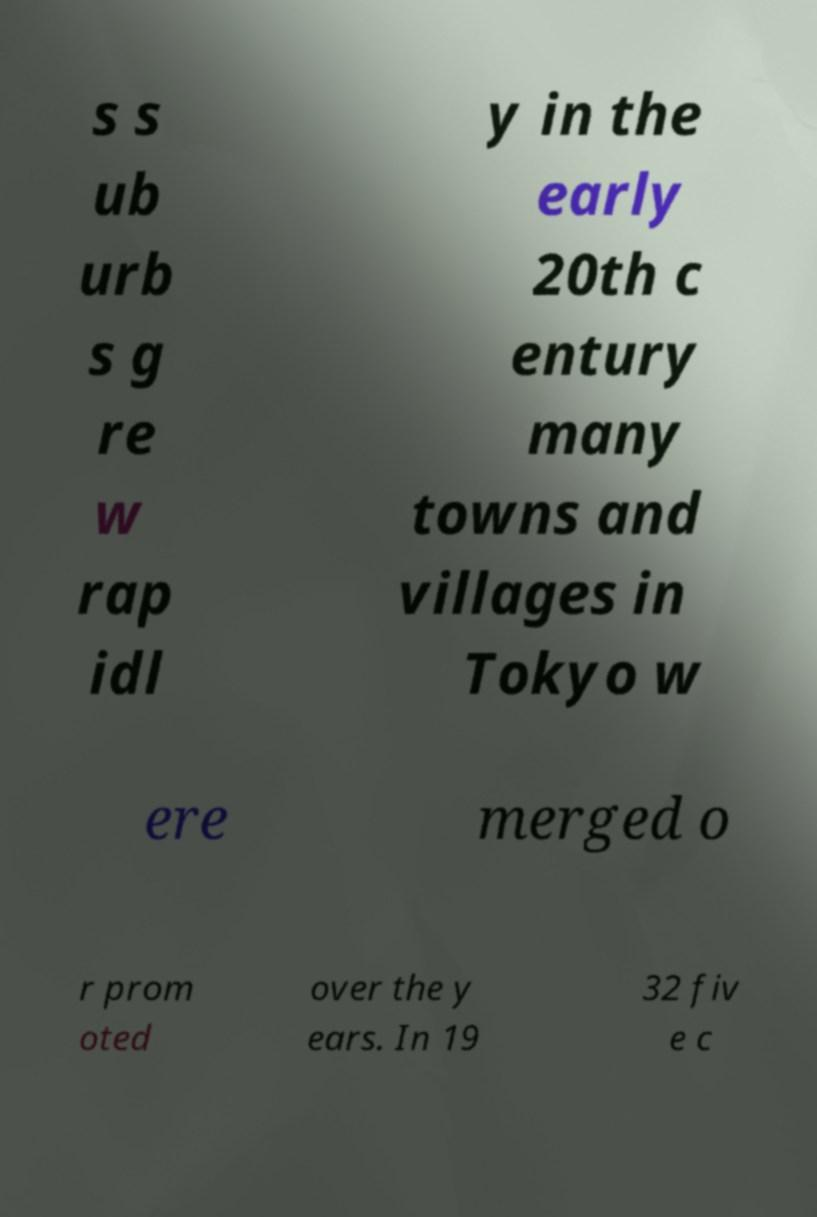There's text embedded in this image that I need extracted. Can you transcribe it verbatim? s s ub urb s g re w rap idl y in the early 20th c entury many towns and villages in Tokyo w ere merged o r prom oted over the y ears. In 19 32 fiv e c 